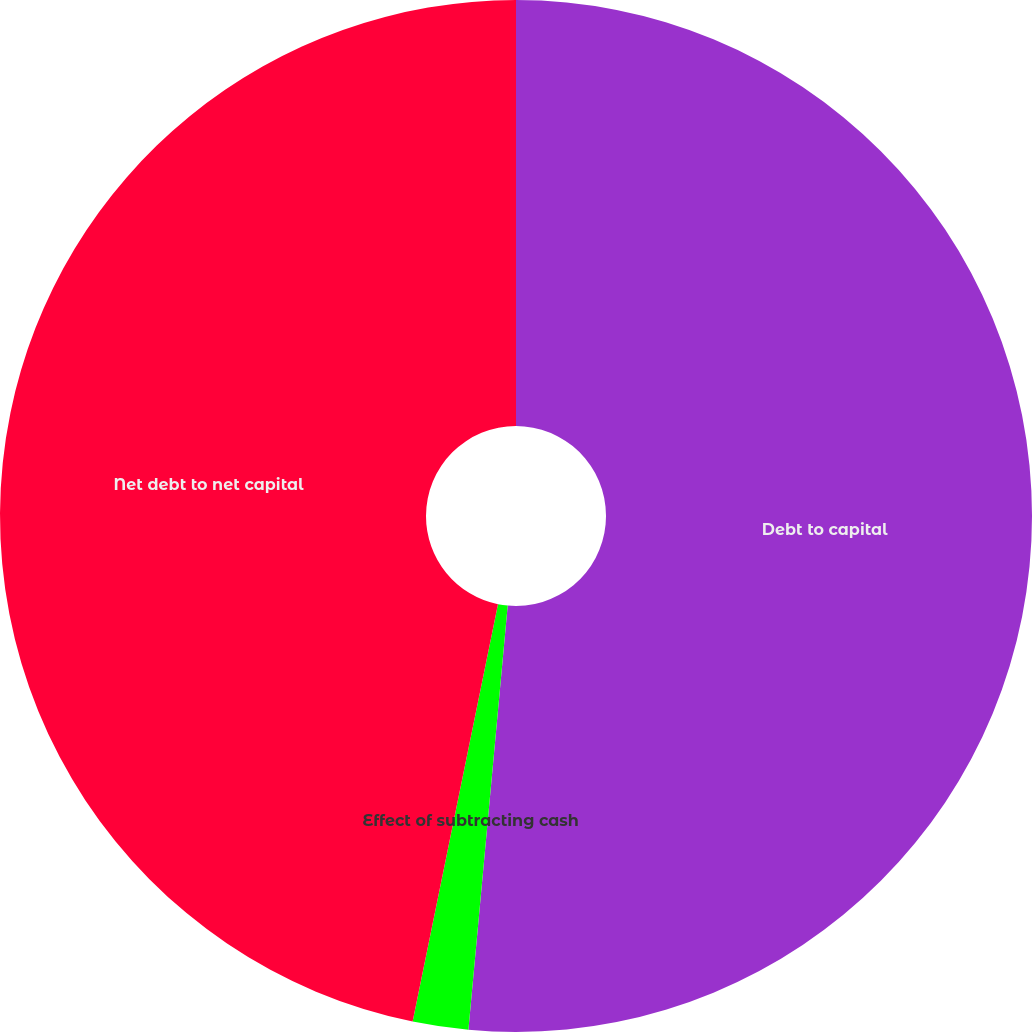<chart> <loc_0><loc_0><loc_500><loc_500><pie_chart><fcel>Debt to capital<fcel>Effect of subtracting cash<fcel>Net debt to net capital<nl><fcel>51.47%<fcel>1.74%<fcel>46.79%<nl></chart> 